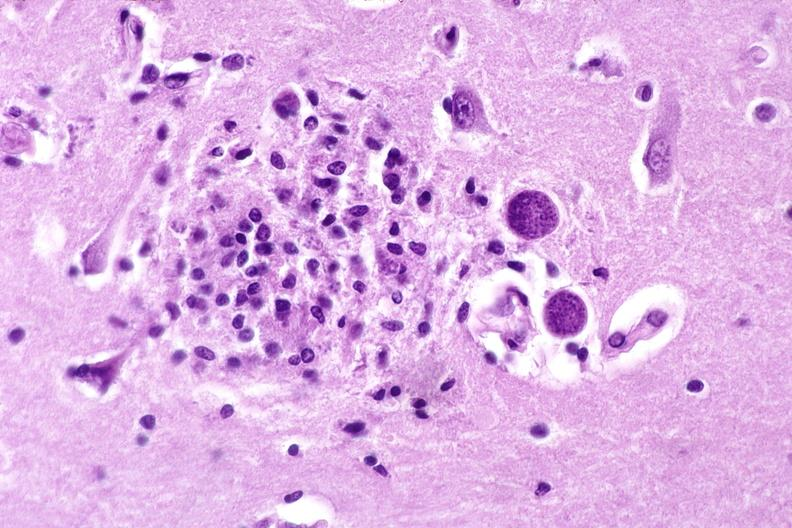does this image show brain, toxoplasma encephalitis?
Answer the question using a single word or phrase. Yes 